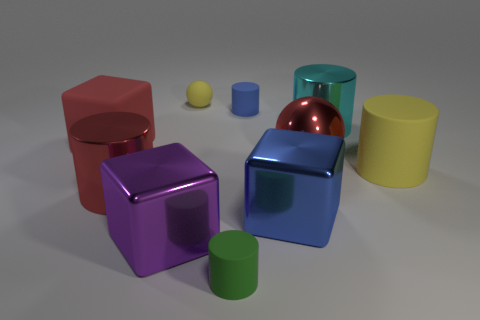Subtract all red cylinders. How many cylinders are left? 4 Subtract all green cylinders. How many cylinders are left? 4 Subtract all purple cylinders. Subtract all purple spheres. How many cylinders are left? 5 Subtract all cubes. How many objects are left? 7 Add 5 purple shiny cylinders. How many purple shiny cylinders exist? 5 Subtract 0 brown balls. How many objects are left? 10 Subtract all large metal balls. Subtract all large cyan metal cylinders. How many objects are left? 8 Add 4 large red shiny cylinders. How many large red shiny cylinders are left? 5 